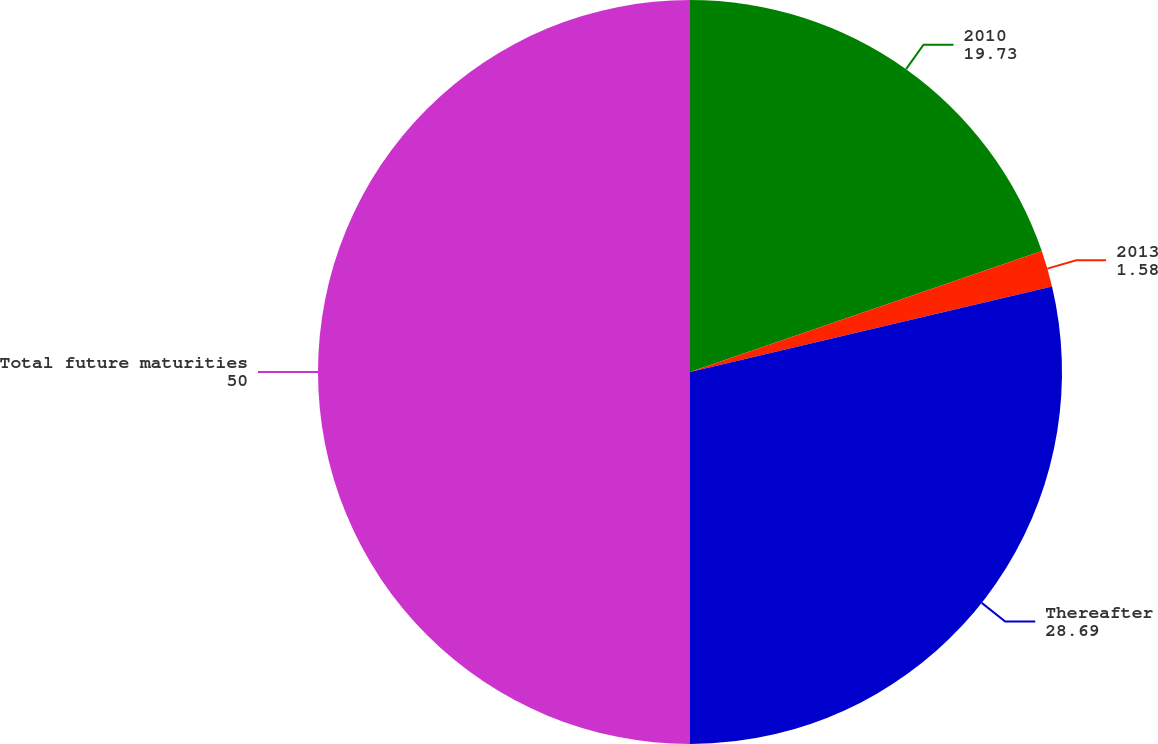Convert chart to OTSL. <chart><loc_0><loc_0><loc_500><loc_500><pie_chart><fcel>2010<fcel>2013<fcel>Thereafter<fcel>Total future maturities<nl><fcel>19.73%<fcel>1.58%<fcel>28.69%<fcel>50.0%<nl></chart> 